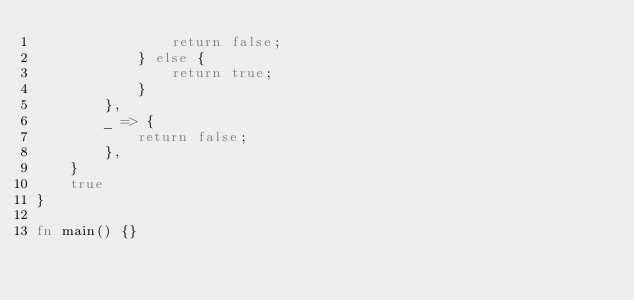Convert code to text. <code><loc_0><loc_0><loc_500><loc_500><_Rust_>                return false;
            } else {
                return true;
            }
        },
        _ => {
            return false;
        },
    }
    true
}

fn main() {}
</code> 